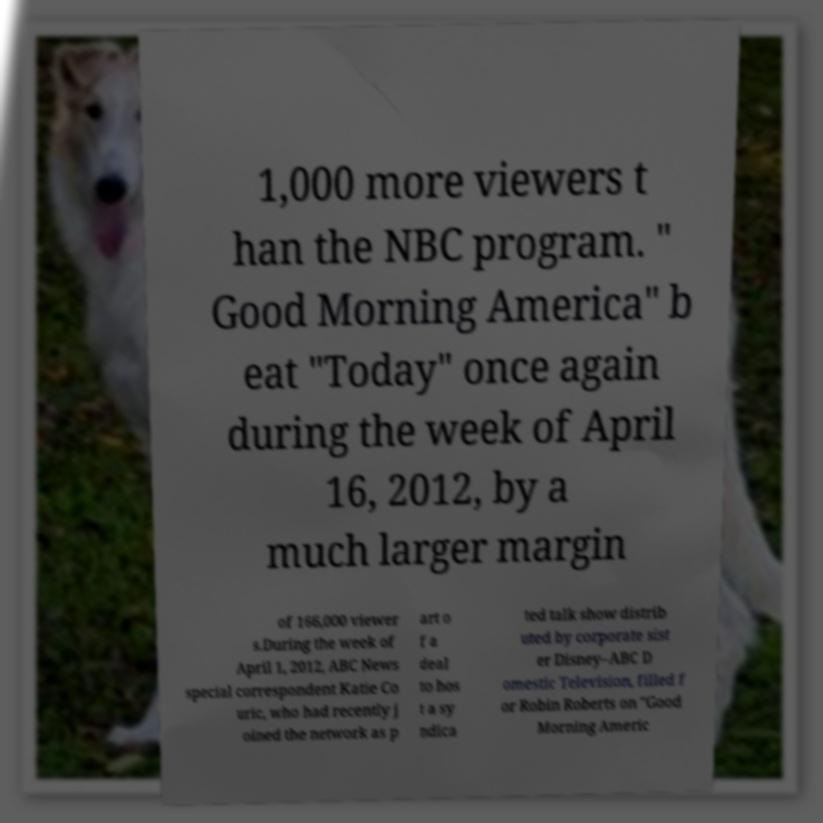For documentation purposes, I need the text within this image transcribed. Could you provide that? 1,000 more viewers t han the NBC program. " Good Morning America" b eat "Today" once again during the week of April 16, 2012, by a much larger margin of 166,000 viewer s.During the week of April 1, 2012, ABC News special correspondent Katie Co uric, who had recently j oined the network as p art o f a deal to hos t a sy ndica ted talk show distrib uted by corporate sist er Disney–ABC D omestic Television, filled f or Robin Roberts on "Good Morning Americ 